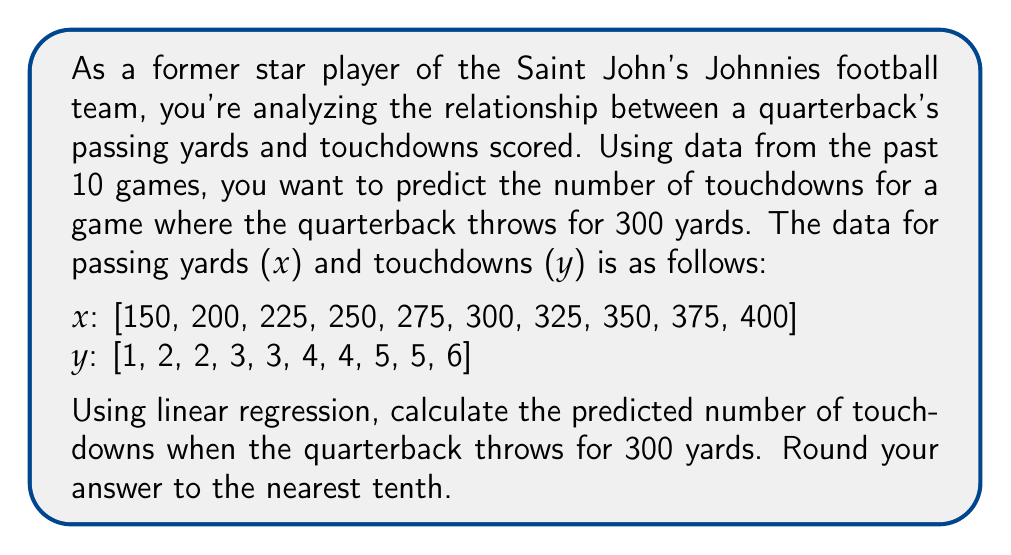Provide a solution to this math problem. To solve this problem, we'll use simple linear regression. The steps are as follows:

1) First, we need to calculate the following sums:
   $\sum x$, $\sum y$, $\sum x^2$, $\sum xy$, and $n$ (number of data points)

   $\sum x = 2850$
   $\sum y = 35$
   $\sum x^2 = 856,250$
   $\sum xy = 10,475$
   $n = 10$

2) Now we can calculate the slope ($m$) and y-intercept ($b$) of the regression line:

   $m = \frac{n\sum xy - \sum x \sum y}{n\sum x^2 - (\sum x)^2}$

   $m = \frac{10(10,475) - 2850(35)}{10(856,250) - 2850^2}$
   $m = \frac{104,750 - 99,750}{8,562,500 - 8,122,500}$
   $m = \frac{5000}{440,000} = \frac{1}{88} \approx 0.0114$

   $b = \frac{\sum y - m\sum x}{n}$

   $b = \frac{35 - 0.0114(2850)}{10}$
   $b = \frac{35 - 32.49}{10} = 0.251$

3) The regression equation is:
   $y = mx + b = 0.0114x + 0.251$

4) To predict the number of touchdowns for 300 passing yards, we substitute $x = 300$:

   $y = 0.0114(300) + 0.251 = 3.671$

5) Rounding to the nearest tenth gives us 3.7.
Answer: 3.7 touchdowns 